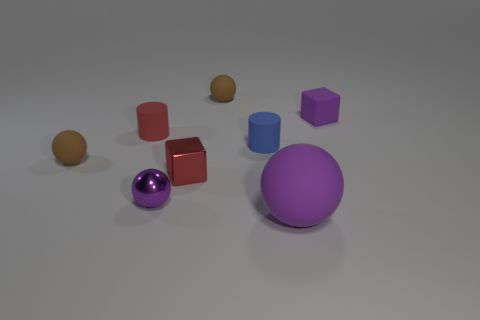There is a tiny purple object that is the same material as the big object; what is its shape?
Keep it short and to the point. Cube. There is a brown object behind the red rubber object; what material is it?
Provide a succinct answer. Rubber. Do the small rubber sphere on the left side of the red block and the tiny rubber block have the same color?
Keep it short and to the point. No. There is a block to the left of the tiny purple matte object right of the big ball; what size is it?
Offer a terse response. Small. Is the number of metal objects in front of the red cube greater than the number of large gray things?
Offer a very short reply. Yes. Is the size of the purple rubber object that is left of the purple rubber cube the same as the purple metallic sphere?
Your response must be concise. No. What is the color of the matte ball that is right of the small purple sphere and behind the big purple matte ball?
Your response must be concise. Brown. What is the shape of the red rubber object that is the same size as the purple cube?
Keep it short and to the point. Cylinder. Are there any cylinders that have the same color as the metallic cube?
Offer a very short reply. Yes. Are there an equal number of large purple matte objects to the right of the big purple sphere and purple metal objects?
Provide a succinct answer. No. 